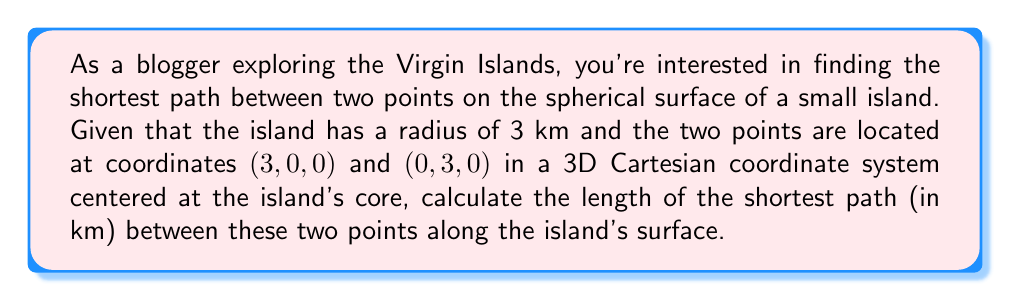Show me your answer to this math problem. To solve this problem, we'll use the concept of great circles, which represent the shortest path between two points on a sphere. Here's a step-by-step solution:

1) First, we need to find the central angle $\theta$ between the two points. We can do this using the dot product of the position vectors:

   $$\cos \theta = \frac{\vec{a} \cdot \vec{b}}{|\vec{a}||\vec{b}|}$$

   Where $\vec{a} = (3, 0, 0)$ and $\vec{b} = (0, 3, 0)$

2) Calculating the dot product:

   $$\vec{a} \cdot \vec{b} = 3 \cdot 0 + 0 \cdot 3 + 0 \cdot 0 = 0$$

3) The magnitude of both vectors is 3:

   $$|\vec{a}| = |\vec{b}| = \sqrt{3^2 + 0^2 + 0^2} = 3$$

4) Substituting into the equation:

   $$\cos \theta = \frac{0}{3 \cdot 3} = 0$$

5) Taking the inverse cosine:

   $$\theta = \arccos(0) = \frac{\pi}{2}$$

6) Now that we have the central angle, we can calculate the arc length using the formula:

   $$s = r\theta$$

   Where $r$ is the radius of the sphere (3 km) and $\theta$ is in radians.

7) Substituting the values:

   $$s = 3 \cdot \frac{\pi}{2} = \frac{3\pi}{2} \approx 4.71 \text{ km}$$

Thus, the shortest path between the two points on the island's surface is approximately 4.71 km.
Answer: $\frac{3\pi}{2}$ km 